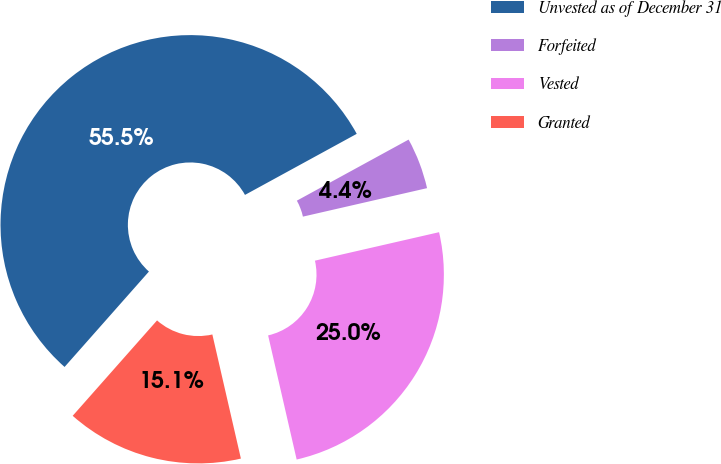Convert chart. <chart><loc_0><loc_0><loc_500><loc_500><pie_chart><fcel>Unvested as of December 31<fcel>Forfeited<fcel>Vested<fcel>Granted<nl><fcel>55.51%<fcel>4.37%<fcel>24.99%<fcel>15.12%<nl></chart> 